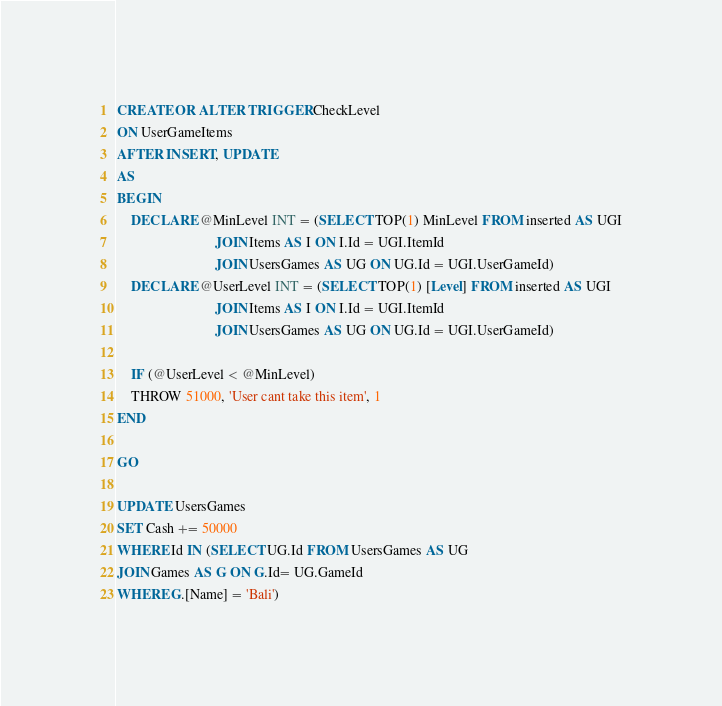<code> <loc_0><loc_0><loc_500><loc_500><_SQL_>CREATE OR ALTER TRIGGER CheckLevel
ON UserGameItems
AFTER INSERT, UPDATE
AS
BEGIN
	DECLARE @MinLevel INT = (SELECT TOP(1) MinLevel FROM inserted AS UGI
							JOIN Items AS I ON I.Id = UGI.ItemId
							JOIN UsersGames AS UG ON UG.Id = UGI.UserGameId)
	DECLARE @UserLevel INT = (SELECT TOP(1) [Level] FROM inserted AS UGI
							JOIN Items AS I ON I.Id = UGI.ItemId
							JOIN UsersGames AS UG ON UG.Id = UGI.UserGameId)

	IF (@UserLevel < @MinLevel)
	THROW 51000, 'User cant take this item', 1
END

GO

UPDATE UsersGames
SET Cash += 50000
WHERE Id IN (SELECT UG.Id FROM UsersGames AS UG
JOIN Games AS G ON G.Id= UG.GameId
WHERE G.[Name] = 'Bali')</code> 